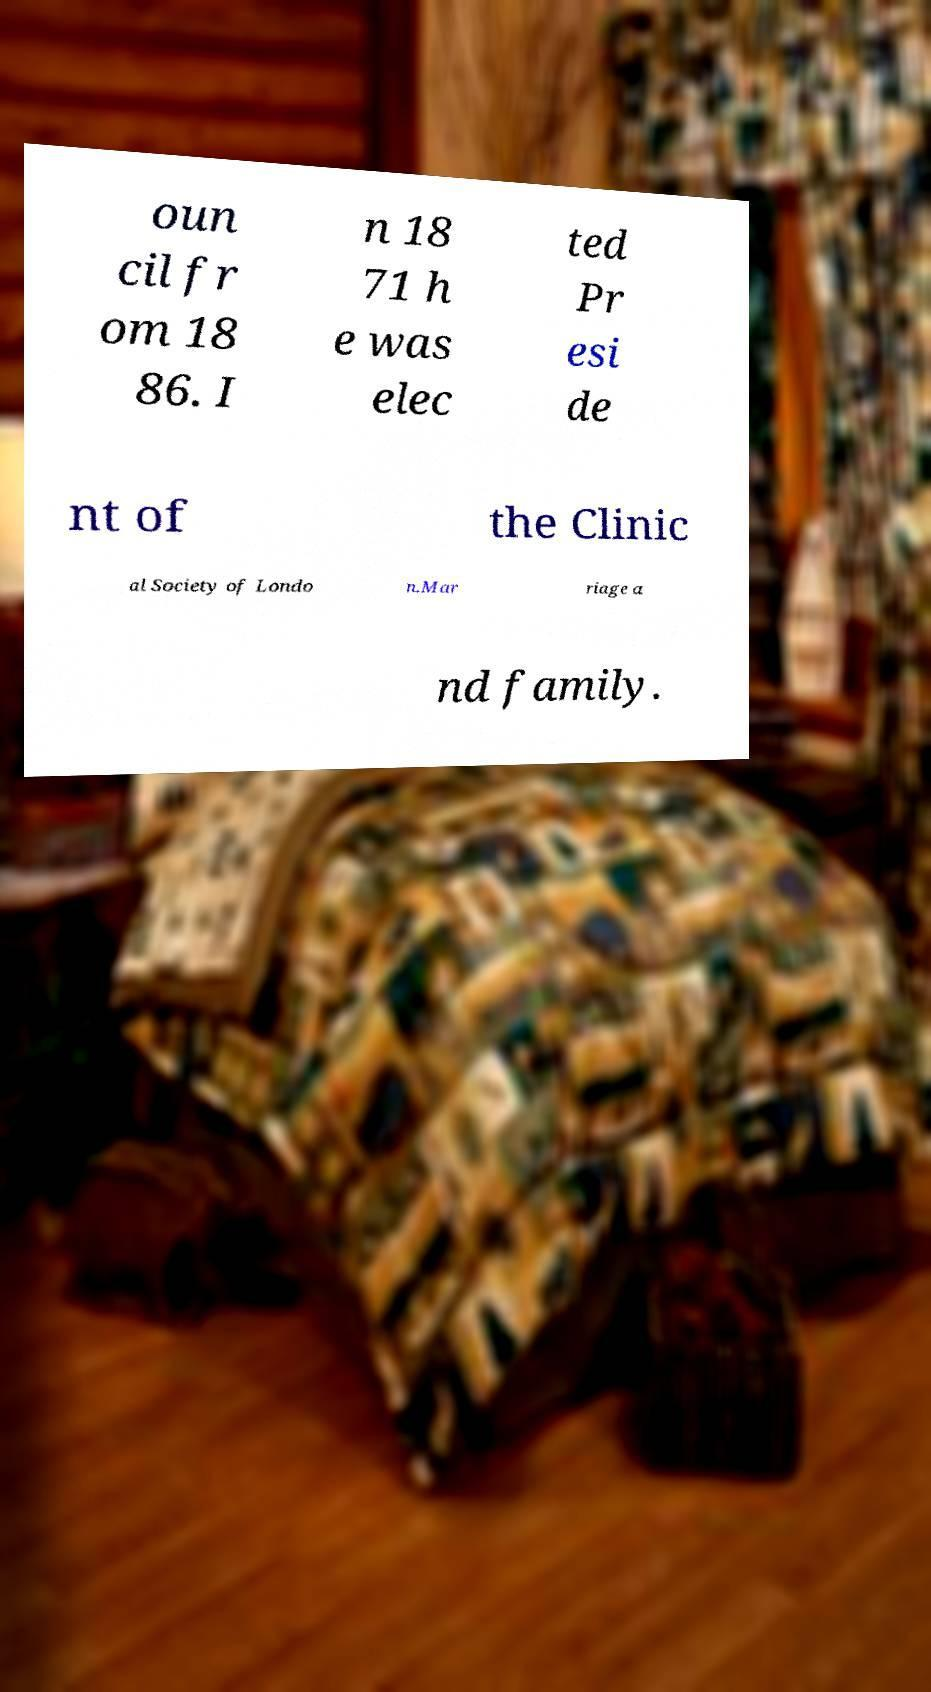I need the written content from this picture converted into text. Can you do that? oun cil fr om 18 86. I n 18 71 h e was elec ted Pr esi de nt of the Clinic al Society of Londo n.Mar riage a nd family. 